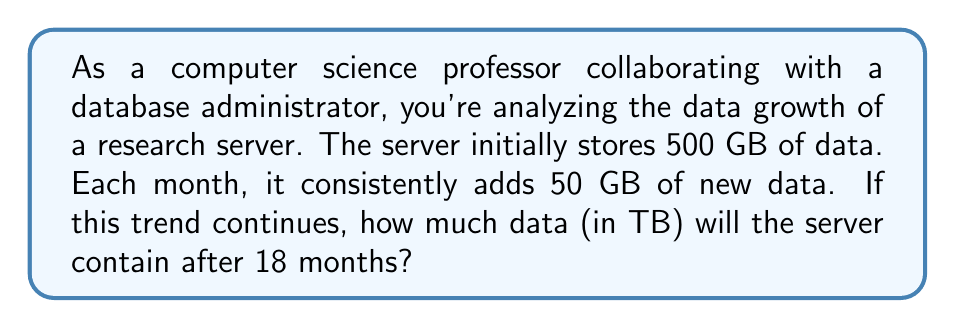Give your solution to this math problem. Let's approach this step-by-step:

1) First, let's identify the important information:
   - Initial data: 500 GB
   - Monthly data increase: 50 GB
   - Time period: 18 months

2) We can set up an equation to represent the total data after 18 months:
   $$\text{Total Data} = \text{Initial Data} + (\text{Monthly Increase} \times \text{Number of Months})$$

3) Plugging in our values:
   $$\text{Total Data} = 500 + (50 \times 18)$$

4) Let's solve the equation:
   $$\text{Total Data} = 500 + 900 = 1400 \text{ GB}$$

5) The question asks for the answer in TB (terabytes). We know that:
   $$1 \text{ TB} = 1000 \text{ GB}$$

6) So, we need to convert 1400 GB to TB:
   $$1400 \text{ GB} = 1400 \div 1000 = 1.4 \text{ TB}$$

Thus, after 18 months, the server will contain 1.4 TB of data.
Answer: 1.4 TB 